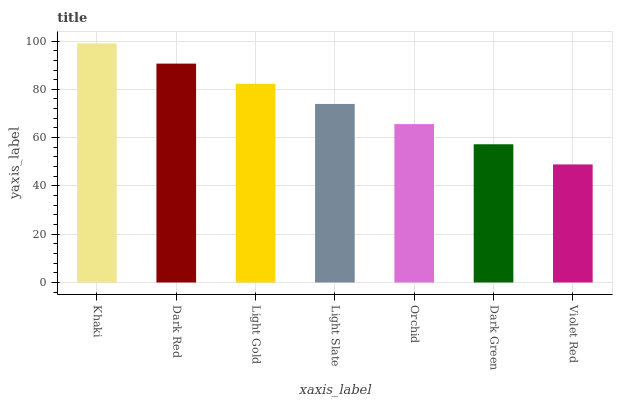Is Violet Red the minimum?
Answer yes or no. Yes. Is Khaki the maximum?
Answer yes or no. Yes. Is Dark Red the minimum?
Answer yes or no. No. Is Dark Red the maximum?
Answer yes or no. No. Is Khaki greater than Dark Red?
Answer yes or no. Yes. Is Dark Red less than Khaki?
Answer yes or no. Yes. Is Dark Red greater than Khaki?
Answer yes or no. No. Is Khaki less than Dark Red?
Answer yes or no. No. Is Light Slate the high median?
Answer yes or no. Yes. Is Light Slate the low median?
Answer yes or no. Yes. Is Orchid the high median?
Answer yes or no. No. Is Violet Red the low median?
Answer yes or no. No. 